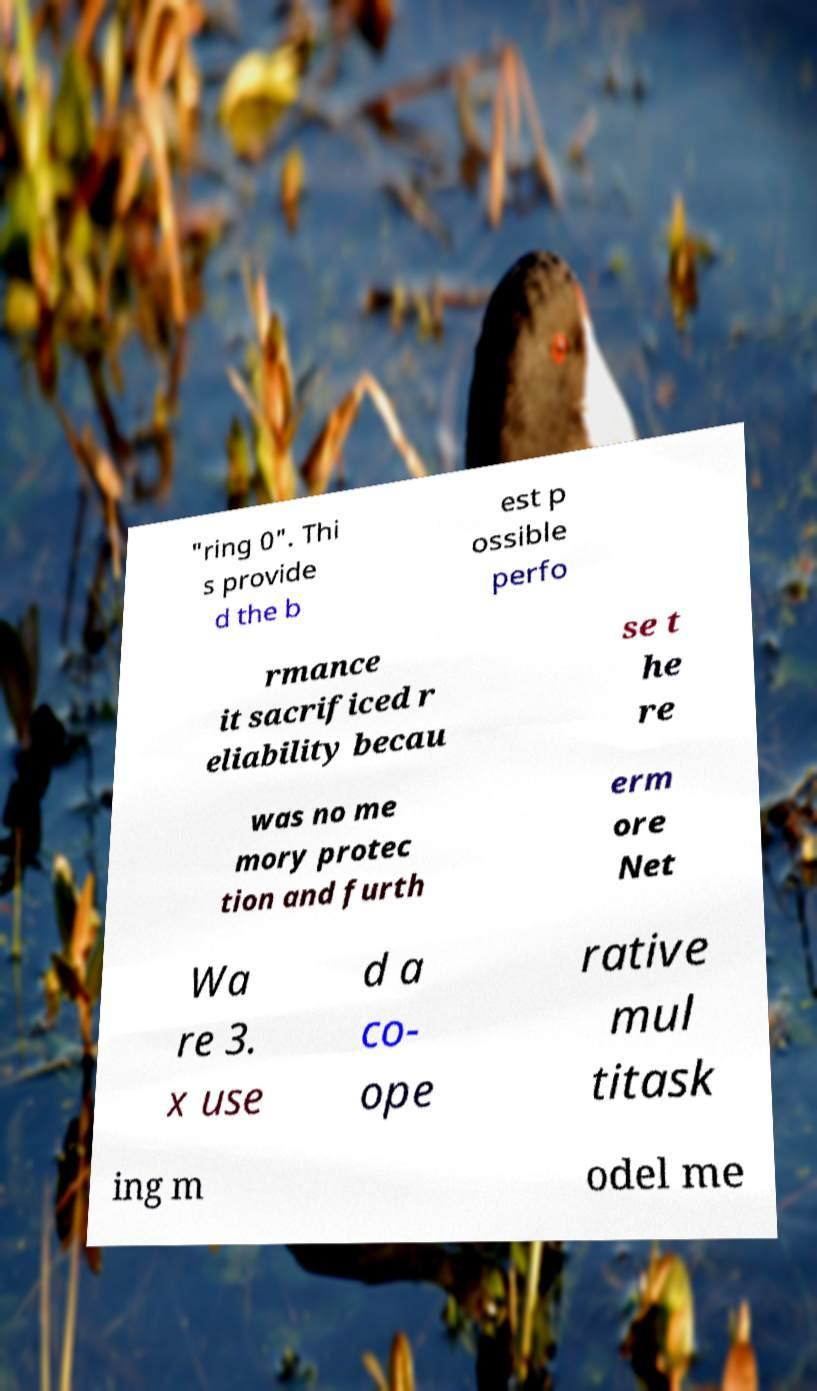Can you accurately transcribe the text from the provided image for me? "ring 0". Thi s provide d the b est p ossible perfo rmance it sacrificed r eliability becau se t he re was no me mory protec tion and furth erm ore Net Wa re 3. x use d a co- ope rative mul titask ing m odel me 